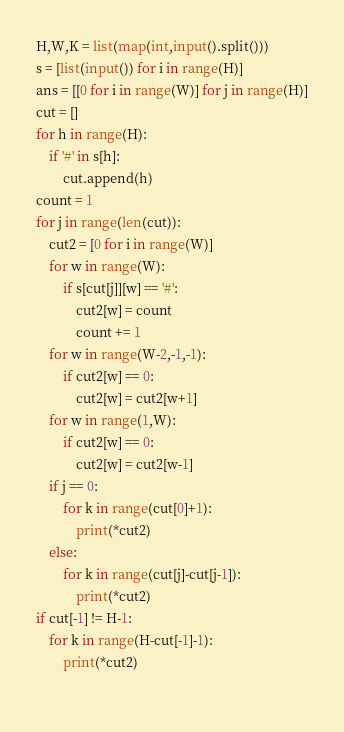Convert code to text. <code><loc_0><loc_0><loc_500><loc_500><_Python_>H,W,K = list(map(int,input().split()))
s = [list(input()) for i in range(H)]
ans = [[0 for i in range(W)] for j in range(H)]
cut = []
for h in range(H):
    if '#' in s[h]:
        cut.append(h)
count = 1
for j in range(len(cut)):
    cut2 = [0 for i in range(W)]
    for w in range(W):
        if s[cut[j]][w] == '#':
            cut2[w] = count
            count += 1
    for w in range(W-2,-1,-1):
        if cut2[w] == 0:
            cut2[w] = cut2[w+1]
    for w in range(1,W):
        if cut2[w] == 0:
            cut2[w] = cut2[w-1]    
    if j == 0:
        for k in range(cut[0]+1):
            print(*cut2)
    else:
        for k in range(cut[j]-cut[j-1]):
            print(*cut2)
if cut[-1] != H-1:
    for k in range(H-cut[-1]-1):
        print(*cut2)
    </code> 